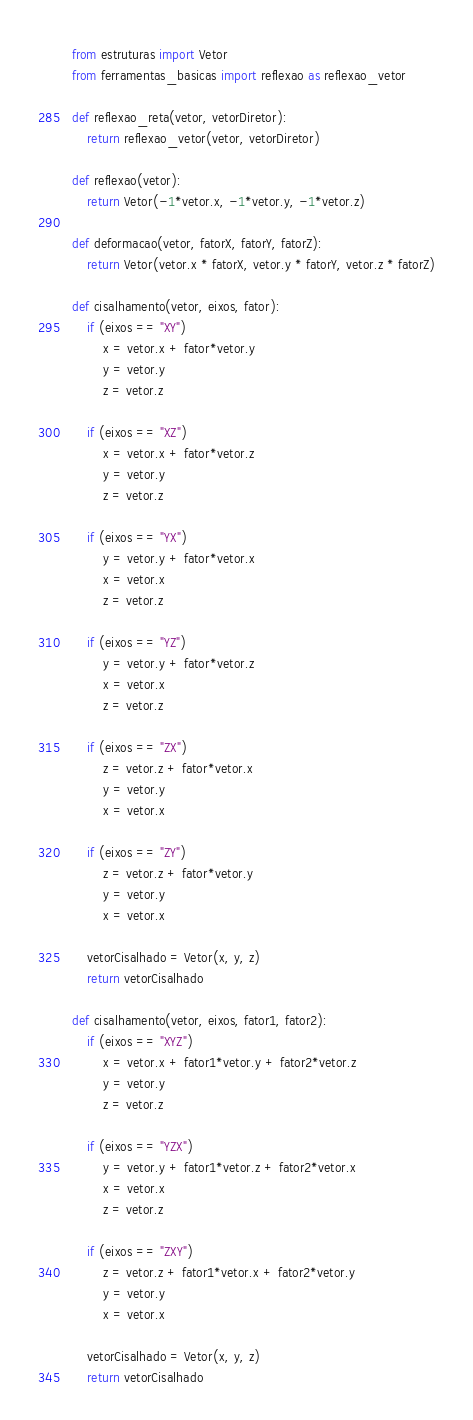<code> <loc_0><loc_0><loc_500><loc_500><_Python_>from estruturas import Vetor
from ferramentas_basicas import reflexao as reflexao_vetor

def reflexao_reta(vetor, vetorDiretor):
    return reflexao_vetor(vetor, vetorDiretor)

def reflexao(vetor):
    return Vetor(-1*vetor.x, -1*vetor.y, -1*vetor.z)

def deformacao(vetor, fatorX, fatorY, fatorZ):
    return Vetor(vetor.x * fatorX, vetor.y * fatorY, vetor.z * fatorZ)

def cisalhamento(vetor, eixos, fator):
    if (eixos == "XY")
        x = vetor.x + fator*vetor.y
        y = vetor.y
        z = vetor.z

    if (eixos == "XZ")
        x = vetor.x + fator*vetor.z
        y = vetor.y
        z = vetor.z

    if (eixos == "YX")
        y = vetor.y + fator*vetor.x
        x = vetor.x
        z = vetor.z

    if (eixos == "YZ")
        y = vetor.y + fator*vetor.z
        x = vetor.x
        z = vetor.z

    if (eixos == "ZX")
        z = vetor.z + fator*vetor.x
        y = vetor.y
        x = vetor.x

    if (eixos == "ZY")
        z = vetor.z + fator*vetor.y
        y = vetor.y
        x = vetor.x

    vetorCisalhado = Vetor(x, y, z)
    return vetorCisalhado

def cisalhamento(vetor, eixos, fator1, fator2):
    if (eixos == "XYZ")
        x = vetor.x + fator1*vetor.y + fator2*vetor.z
        y = vetor.y
        z = vetor.z

    if (eixos == "YZX")
        y = vetor.y + fator1*vetor.z + fator2*vetor.x
        x = vetor.x
        z = vetor.z

    if (eixos == "ZXY")
        z = vetor.z + fator1*vetor.x + fator2*vetor.y
        y = vetor.y
        x = vetor.x

    vetorCisalhado = Vetor(x, y, z)
    return vetorCisalhado
</code> 